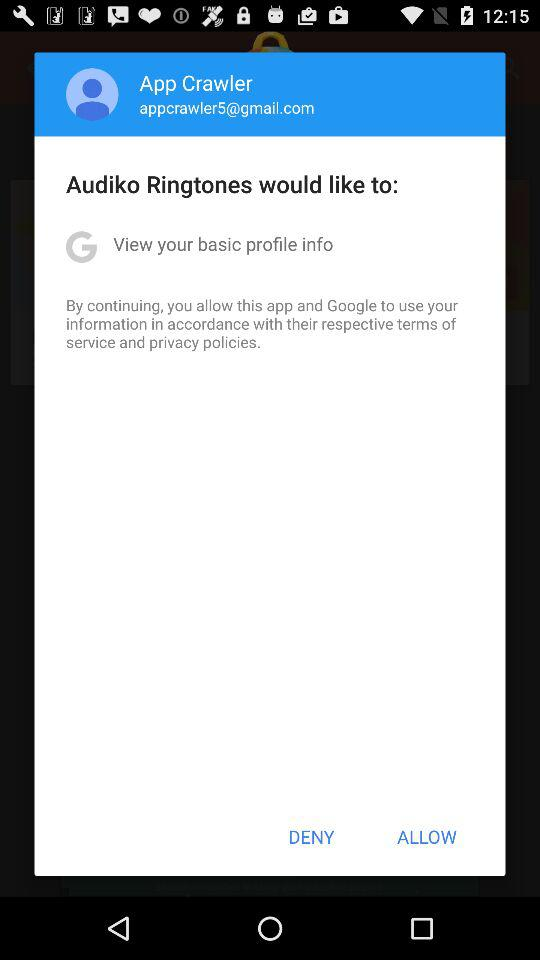What is the email address? The email address is appcrawler5@gmail.com. 